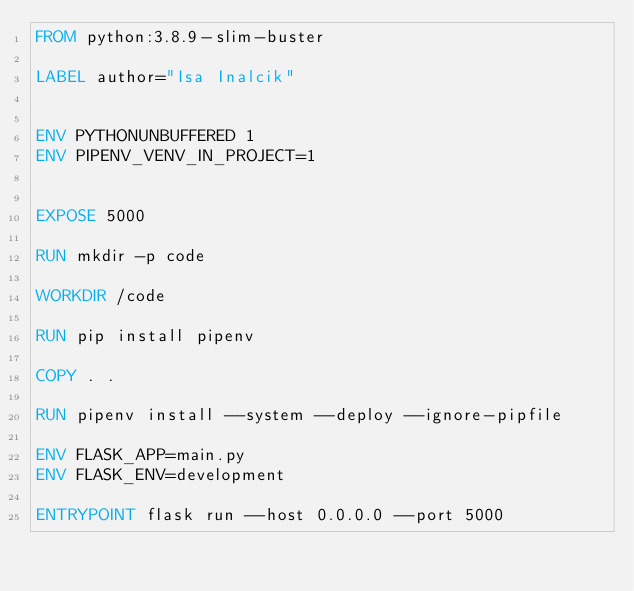<code> <loc_0><loc_0><loc_500><loc_500><_Dockerfile_>FROM python:3.8.9-slim-buster

LABEL author="Isa Inalcik"


ENV PYTHONUNBUFFERED 1
ENV PIPENV_VENV_IN_PROJECT=1 


EXPOSE 5000

RUN mkdir -p code

WORKDIR /code

RUN pip install pipenv

COPY . .

RUN pipenv install --system --deploy --ignore-pipfile

ENV FLASK_APP=main.py
ENV FLASK_ENV=development

ENTRYPOINT flask run --host 0.0.0.0 --port 5000

</code> 